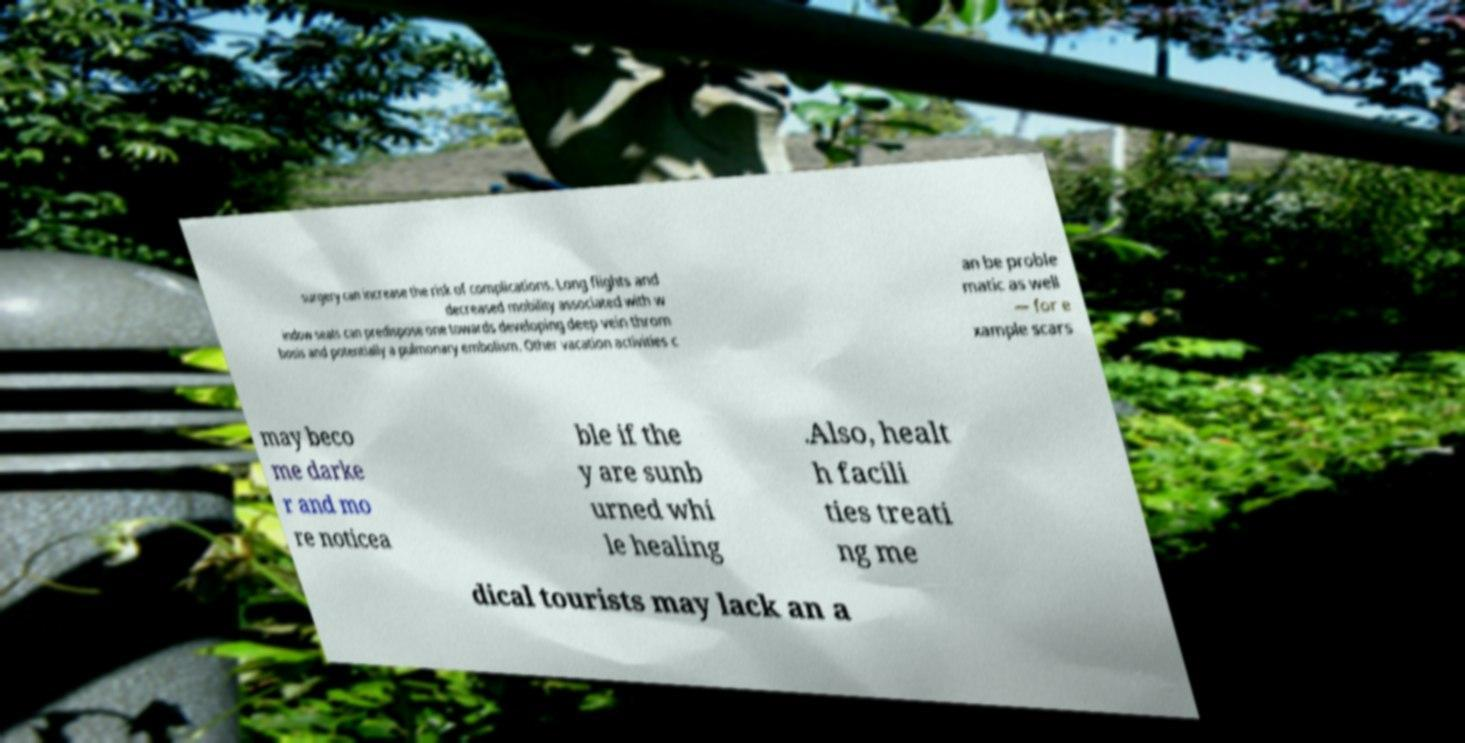I need the written content from this picture converted into text. Can you do that? surgery can increase the risk of complications. Long flights and decreased mobility associated with w indow seats can predispose one towards developing deep vein throm bosis and potentially a pulmonary embolism. Other vacation activities c an be proble matic as well — for e xample scars may beco me darke r and mo re noticea ble if the y are sunb urned whi le healing .Also, healt h facili ties treati ng me dical tourists may lack an a 